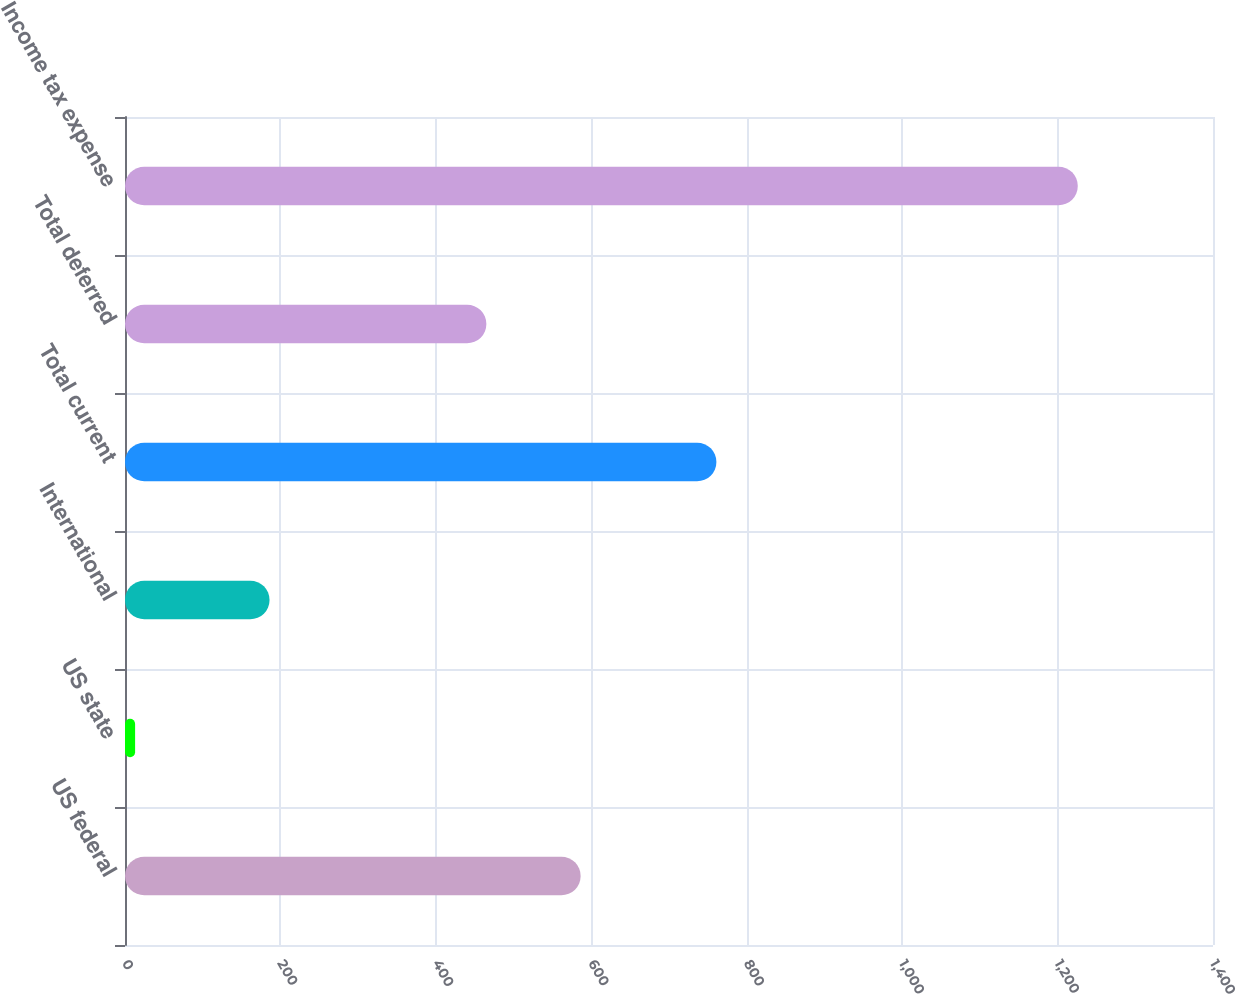Convert chart. <chart><loc_0><loc_0><loc_500><loc_500><bar_chart><fcel>US federal<fcel>US state<fcel>International<fcel>Total current<fcel>Total deferred<fcel>Income tax expense<nl><fcel>586.3<fcel>13<fcel>186<fcel>761<fcel>465<fcel>1226<nl></chart> 